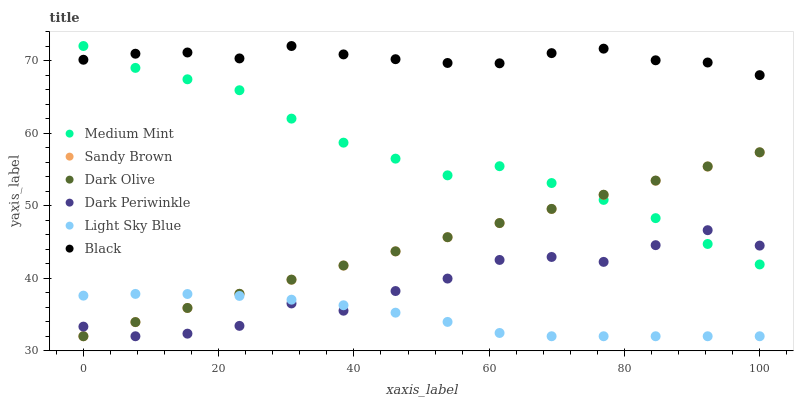Does Light Sky Blue have the minimum area under the curve?
Answer yes or no. Yes. Does Black have the maximum area under the curve?
Answer yes or no. Yes. Does Dark Olive have the minimum area under the curve?
Answer yes or no. No. Does Dark Olive have the maximum area under the curve?
Answer yes or no. No. Is Sandy Brown the smoothest?
Answer yes or no. Yes. Is Dark Periwinkle the roughest?
Answer yes or no. Yes. Is Dark Olive the smoothest?
Answer yes or no. No. Is Dark Olive the roughest?
Answer yes or no. No. Does Dark Olive have the lowest value?
Answer yes or no. Yes. Does Black have the lowest value?
Answer yes or no. No. Does Black have the highest value?
Answer yes or no. Yes. Does Dark Olive have the highest value?
Answer yes or no. No. Is Light Sky Blue less than Medium Mint?
Answer yes or no. Yes. Is Black greater than Light Sky Blue?
Answer yes or no. Yes. Does Dark Periwinkle intersect Dark Olive?
Answer yes or no. Yes. Is Dark Periwinkle less than Dark Olive?
Answer yes or no. No. Is Dark Periwinkle greater than Dark Olive?
Answer yes or no. No. Does Light Sky Blue intersect Medium Mint?
Answer yes or no. No. 